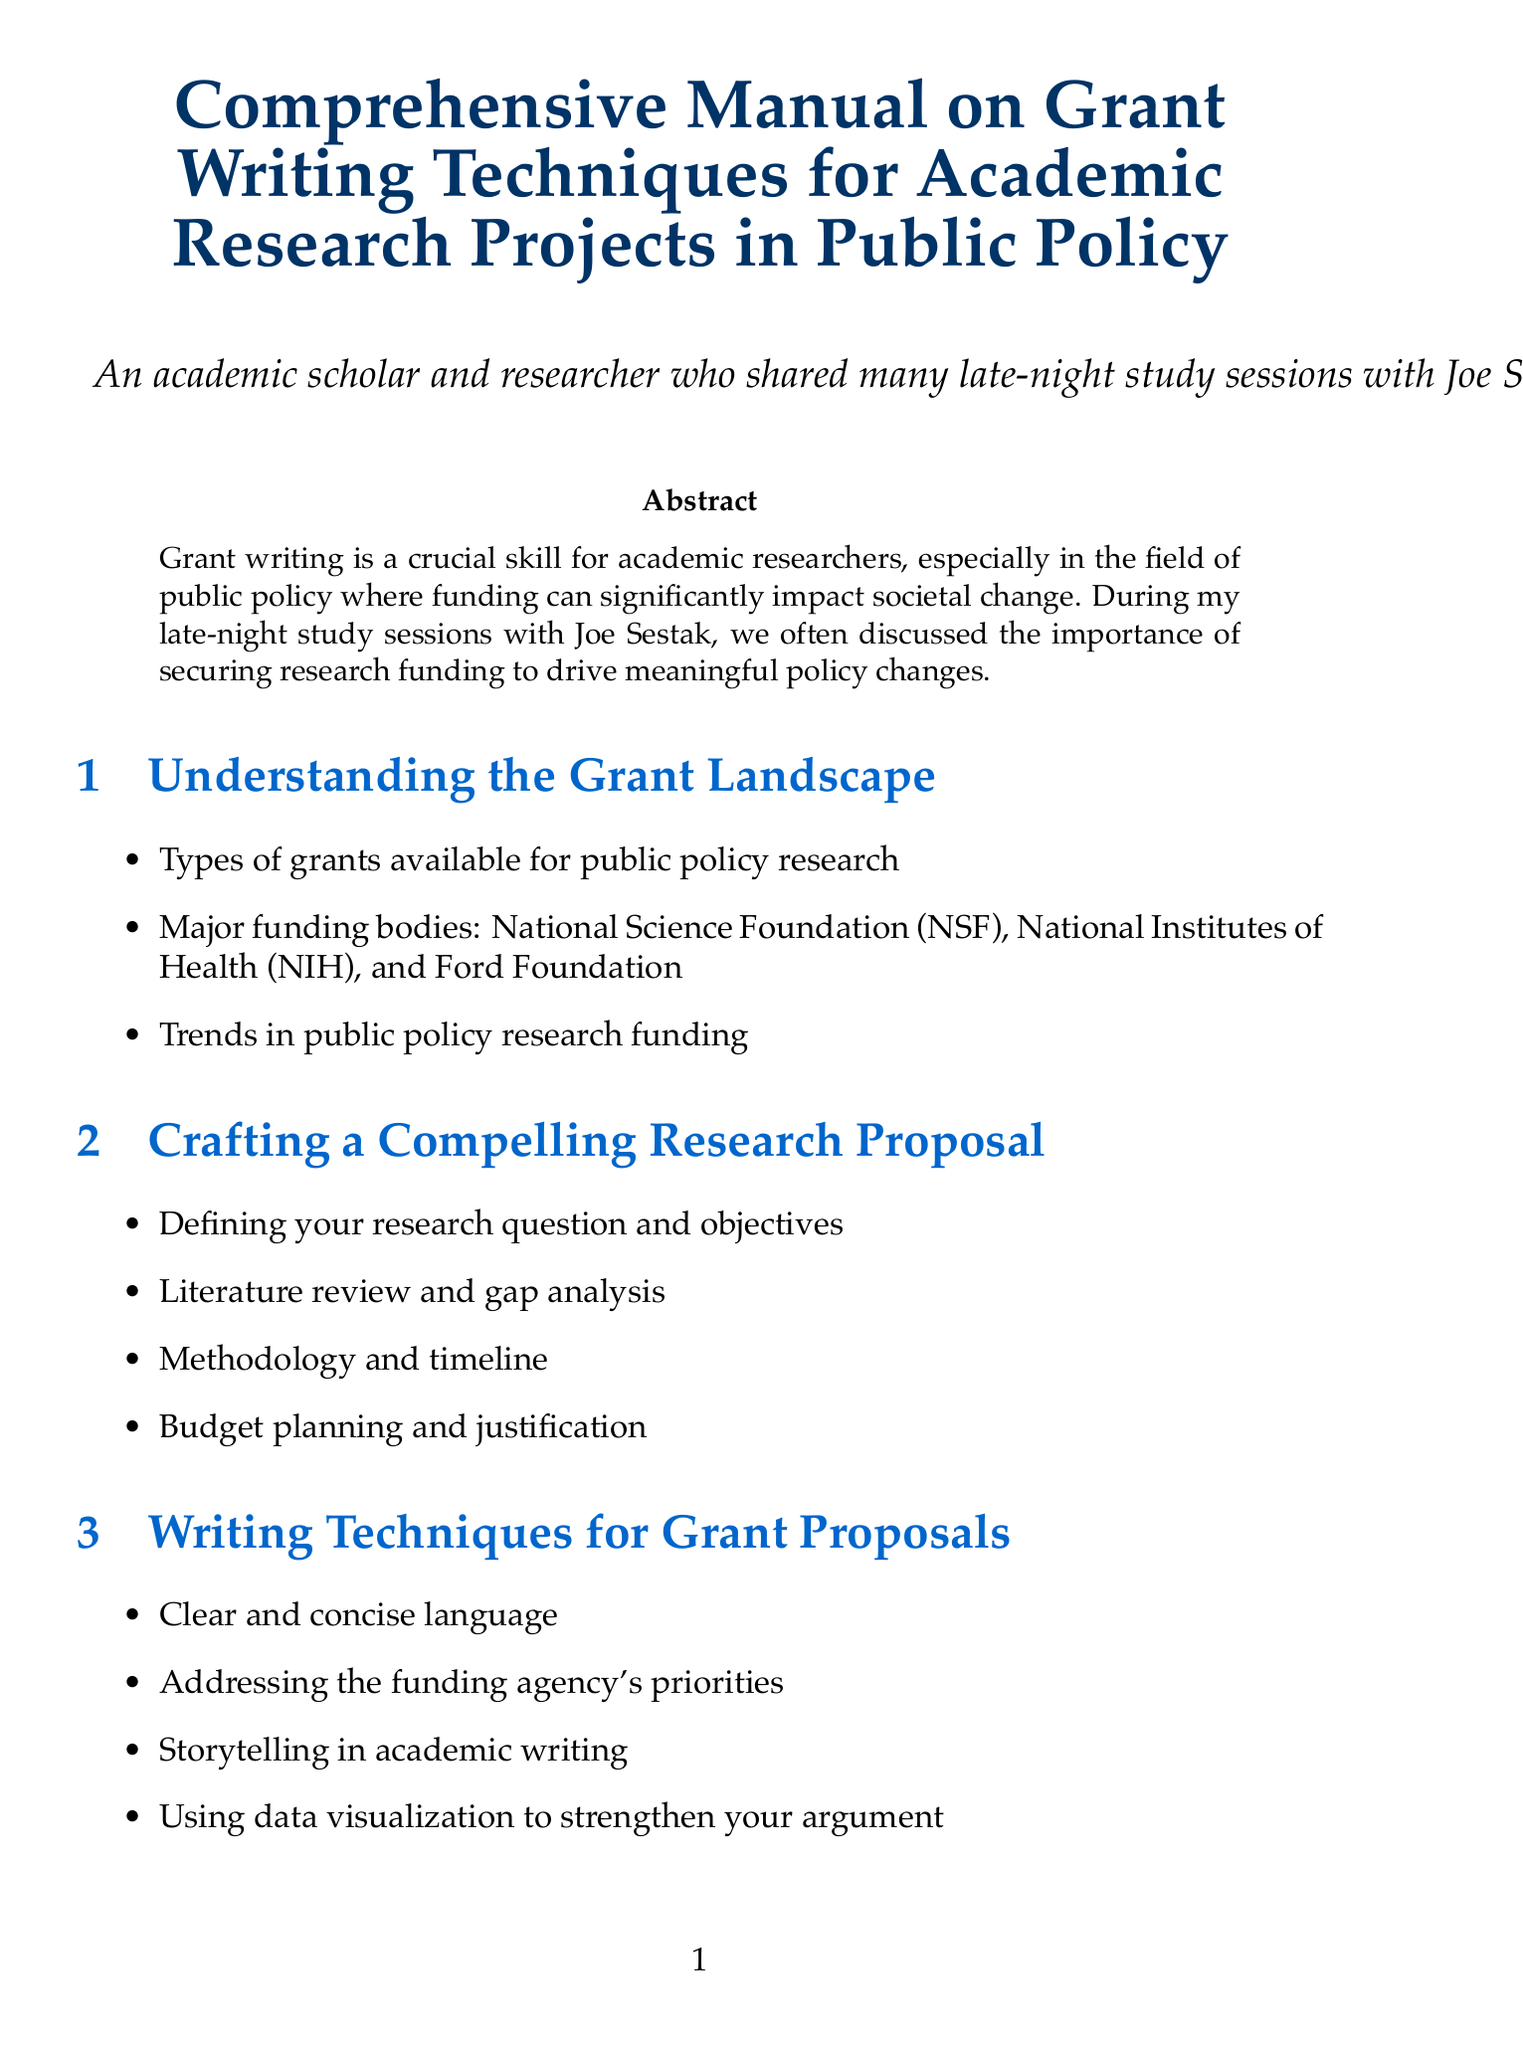What is the title of the manual? The title is explicitly mentioned at the beginning of the document, which summarizes its content.
Answer: Comprehensive Manual on Grant Writing Techniques for Academic Research Projects in Public Policy Who is the principal investigator for the proposal on charter schools? The document lists specific examples of successful proposals, including the names of principal investigators associated with each.
Answer: Dr. Sarah Johnson, Harvard University What major funding body is associated with climate change research? The document names specific funding bodies relevant to public policy research and their corresponding grant areas.
Answer: National Oceanic and Atmospheric Administration (NOAA) What is a key writing technique emphasized in the manual? The manual specifies several writing techniques essential for crafting compelling grant proposals.
Answer: Clear and concise language How many case studies are presented in the manual? The document provides a specific number of case studies in the section dedicated to examples of successful proposals.
Answer: Three What is mentioned as a component of effective collaboration in grant writing? The manual outlines various aspects of collaborative grant writing, including teamwork and resource management.
Answer: Building interdisciplinary research teams Which appendices are included in the manual? The document lists appendices providing additional resources relevant to grant writing.
Answer: Sample Budget Template, Glossary of Grant Writing Terms, Resources for Further Learning What is one of the ethical considerations in grant writing mentioned? The manual discusses ethics throughout the grant writing process, mentioning several key considerations.
Answer: Addressing potential conflicts of interest 